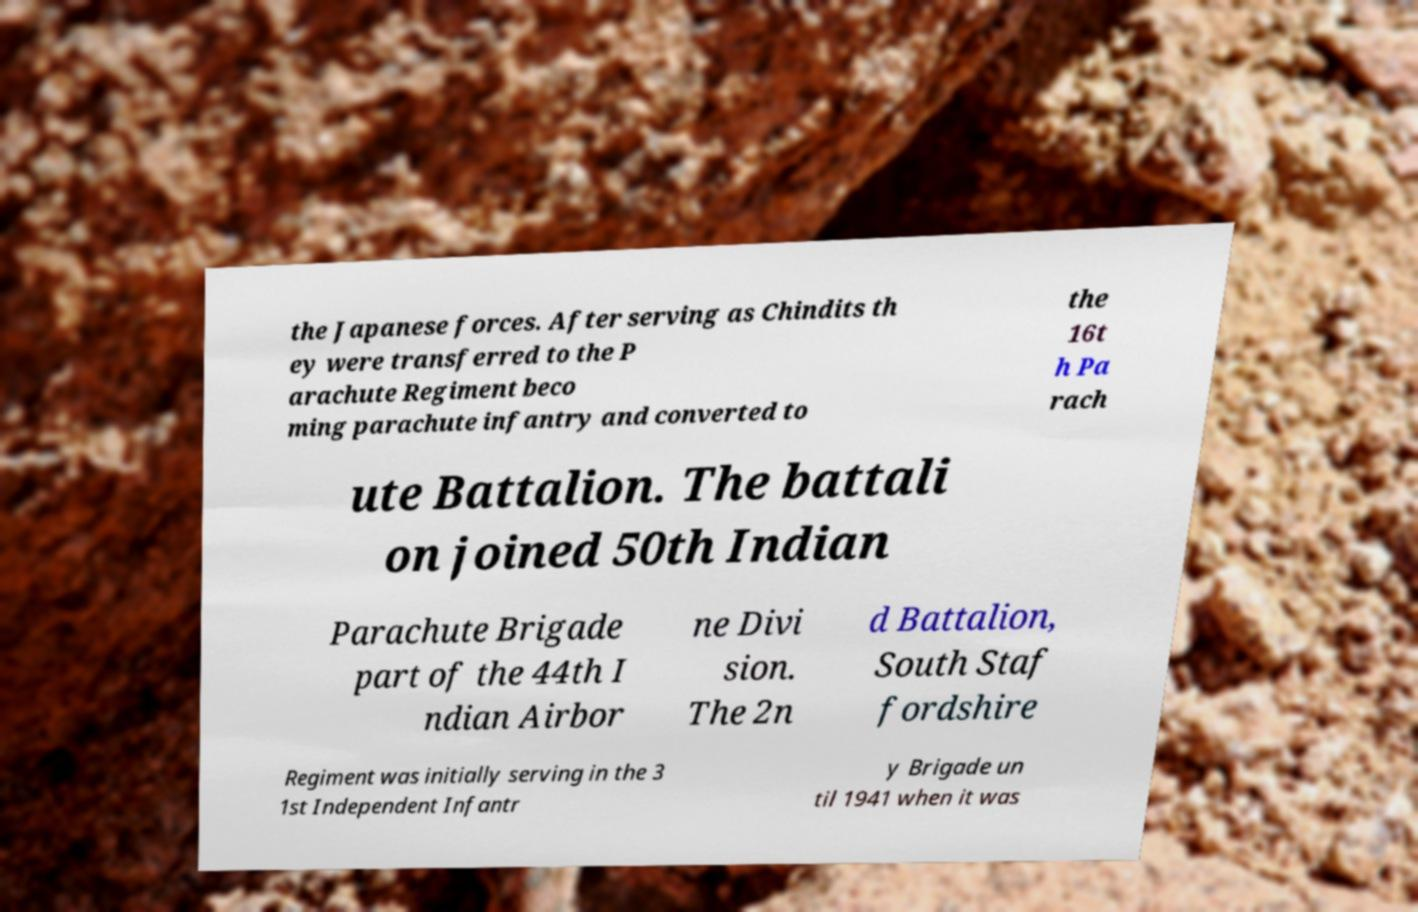Could you extract and type out the text from this image? the Japanese forces. After serving as Chindits th ey were transferred to the P arachute Regiment beco ming parachute infantry and converted to the 16t h Pa rach ute Battalion. The battali on joined 50th Indian Parachute Brigade part of the 44th I ndian Airbor ne Divi sion. The 2n d Battalion, South Staf fordshire Regiment was initially serving in the 3 1st Independent Infantr y Brigade un til 1941 when it was 